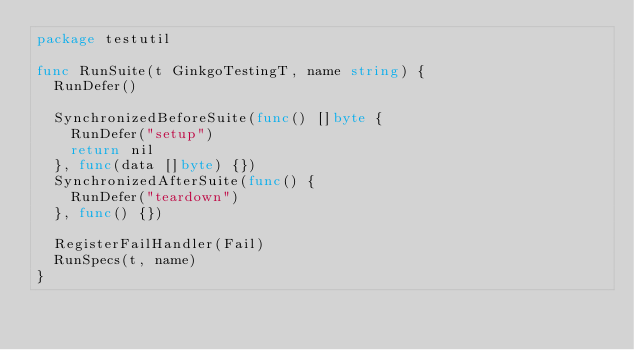<code> <loc_0><loc_0><loc_500><loc_500><_Go_>package testutil

func RunSuite(t GinkgoTestingT, name string) {
	RunDefer()

	SynchronizedBeforeSuite(func() []byte {
		RunDefer("setup")
		return nil
	}, func(data []byte) {})
	SynchronizedAfterSuite(func() {
		RunDefer("teardown")
	}, func() {})

	RegisterFailHandler(Fail)
	RunSpecs(t, name)
}
</code> 